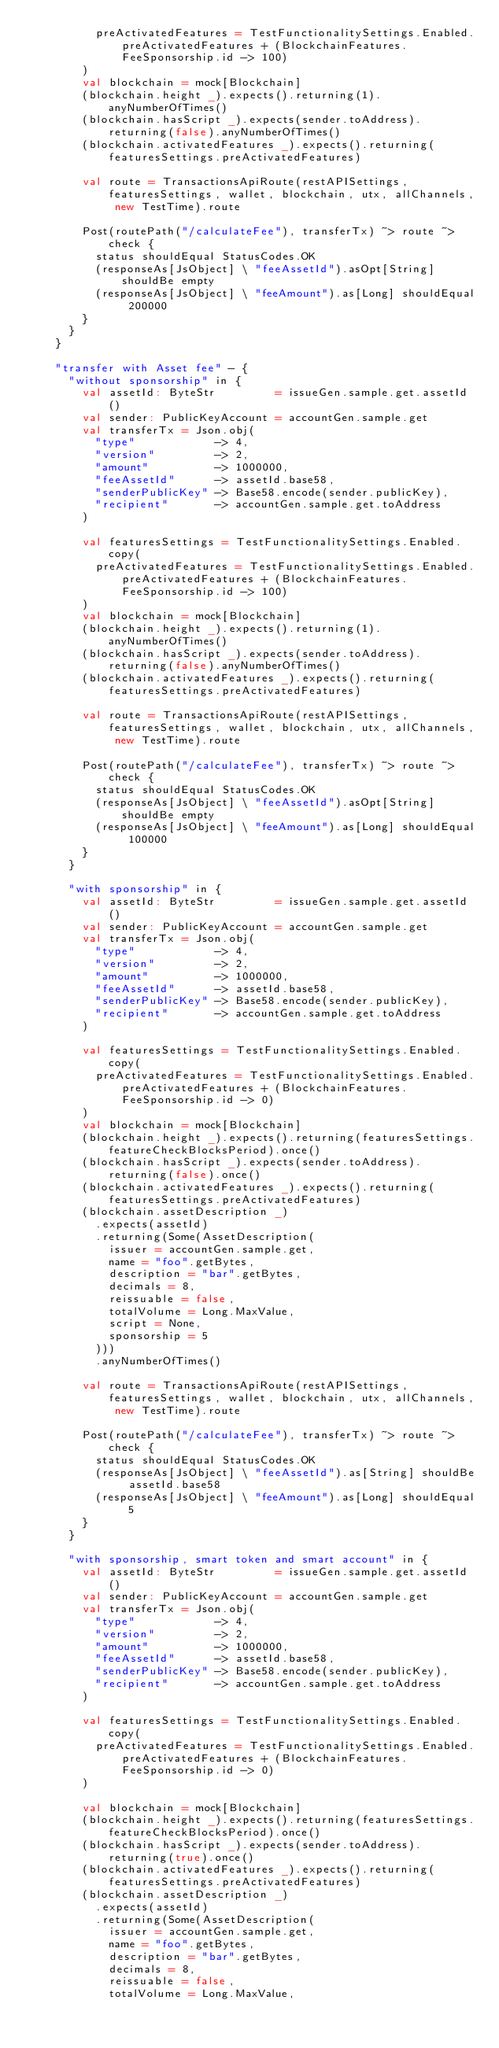<code> <loc_0><loc_0><loc_500><loc_500><_Scala_>          preActivatedFeatures = TestFunctionalitySettings.Enabled.preActivatedFeatures + (BlockchainFeatures.FeeSponsorship.id -> 100)
        )
        val blockchain = mock[Blockchain]
        (blockchain.height _).expects().returning(1).anyNumberOfTimes()
        (blockchain.hasScript _).expects(sender.toAddress).returning(false).anyNumberOfTimes()
        (blockchain.activatedFeatures _).expects().returning(featuresSettings.preActivatedFeatures)

        val route = TransactionsApiRoute(restAPISettings, featuresSettings, wallet, blockchain, utx, allChannels, new TestTime).route

        Post(routePath("/calculateFee"), transferTx) ~> route ~> check {
          status shouldEqual StatusCodes.OK
          (responseAs[JsObject] \ "feeAssetId").asOpt[String] shouldBe empty
          (responseAs[JsObject] \ "feeAmount").as[Long] shouldEqual 200000
        }
      }
    }

    "transfer with Asset fee" - {
      "without sponsorship" in {
        val assetId: ByteStr         = issueGen.sample.get.assetId()
        val sender: PublicKeyAccount = accountGen.sample.get
        val transferTx = Json.obj(
          "type"            -> 4,
          "version"         -> 2,
          "amount"          -> 1000000,
          "feeAssetId"      -> assetId.base58,
          "senderPublicKey" -> Base58.encode(sender.publicKey),
          "recipient"       -> accountGen.sample.get.toAddress
        )

        val featuresSettings = TestFunctionalitySettings.Enabled.copy(
          preActivatedFeatures = TestFunctionalitySettings.Enabled.preActivatedFeatures + (BlockchainFeatures.FeeSponsorship.id -> 100)
        )
        val blockchain = mock[Blockchain]
        (blockchain.height _).expects().returning(1).anyNumberOfTimes()
        (blockchain.hasScript _).expects(sender.toAddress).returning(false).anyNumberOfTimes()
        (blockchain.activatedFeatures _).expects().returning(featuresSettings.preActivatedFeatures)

        val route = TransactionsApiRoute(restAPISettings, featuresSettings, wallet, blockchain, utx, allChannels, new TestTime).route

        Post(routePath("/calculateFee"), transferTx) ~> route ~> check {
          status shouldEqual StatusCodes.OK
          (responseAs[JsObject] \ "feeAssetId").asOpt[String] shouldBe empty
          (responseAs[JsObject] \ "feeAmount").as[Long] shouldEqual 100000
        }
      }

      "with sponsorship" in {
        val assetId: ByteStr         = issueGen.sample.get.assetId()
        val sender: PublicKeyAccount = accountGen.sample.get
        val transferTx = Json.obj(
          "type"            -> 4,
          "version"         -> 2,
          "amount"          -> 1000000,
          "feeAssetId"      -> assetId.base58,
          "senderPublicKey" -> Base58.encode(sender.publicKey),
          "recipient"       -> accountGen.sample.get.toAddress
        )

        val featuresSettings = TestFunctionalitySettings.Enabled.copy(
          preActivatedFeatures = TestFunctionalitySettings.Enabled.preActivatedFeatures + (BlockchainFeatures.FeeSponsorship.id -> 0)
        )
        val blockchain = mock[Blockchain]
        (blockchain.height _).expects().returning(featuresSettings.featureCheckBlocksPeriod).once()
        (blockchain.hasScript _).expects(sender.toAddress).returning(false).once()
        (blockchain.activatedFeatures _).expects().returning(featuresSettings.preActivatedFeatures)
        (blockchain.assetDescription _)
          .expects(assetId)
          .returning(Some(AssetDescription(
            issuer = accountGen.sample.get,
            name = "foo".getBytes,
            description = "bar".getBytes,
            decimals = 8,
            reissuable = false,
            totalVolume = Long.MaxValue,
            script = None,
            sponsorship = 5
          )))
          .anyNumberOfTimes()

        val route = TransactionsApiRoute(restAPISettings, featuresSettings, wallet, blockchain, utx, allChannels, new TestTime).route

        Post(routePath("/calculateFee"), transferTx) ~> route ~> check {
          status shouldEqual StatusCodes.OK
          (responseAs[JsObject] \ "feeAssetId").as[String] shouldBe assetId.base58
          (responseAs[JsObject] \ "feeAmount").as[Long] shouldEqual 5
        }
      }

      "with sponsorship, smart token and smart account" in {
        val assetId: ByteStr         = issueGen.sample.get.assetId()
        val sender: PublicKeyAccount = accountGen.sample.get
        val transferTx = Json.obj(
          "type"            -> 4,
          "version"         -> 2,
          "amount"          -> 1000000,
          "feeAssetId"      -> assetId.base58,
          "senderPublicKey" -> Base58.encode(sender.publicKey),
          "recipient"       -> accountGen.sample.get.toAddress
        )

        val featuresSettings = TestFunctionalitySettings.Enabled.copy(
          preActivatedFeatures = TestFunctionalitySettings.Enabled.preActivatedFeatures + (BlockchainFeatures.FeeSponsorship.id -> 0)
        )

        val blockchain = mock[Blockchain]
        (blockchain.height _).expects().returning(featuresSettings.featureCheckBlocksPeriod).once()
        (blockchain.hasScript _).expects(sender.toAddress).returning(true).once()
        (blockchain.activatedFeatures _).expects().returning(featuresSettings.preActivatedFeatures)
        (blockchain.assetDescription _)
          .expects(assetId)
          .returning(Some(AssetDescription(
            issuer = accountGen.sample.get,
            name = "foo".getBytes,
            description = "bar".getBytes,
            decimals = 8,
            reissuable = false,
            totalVolume = Long.MaxValue,</code> 